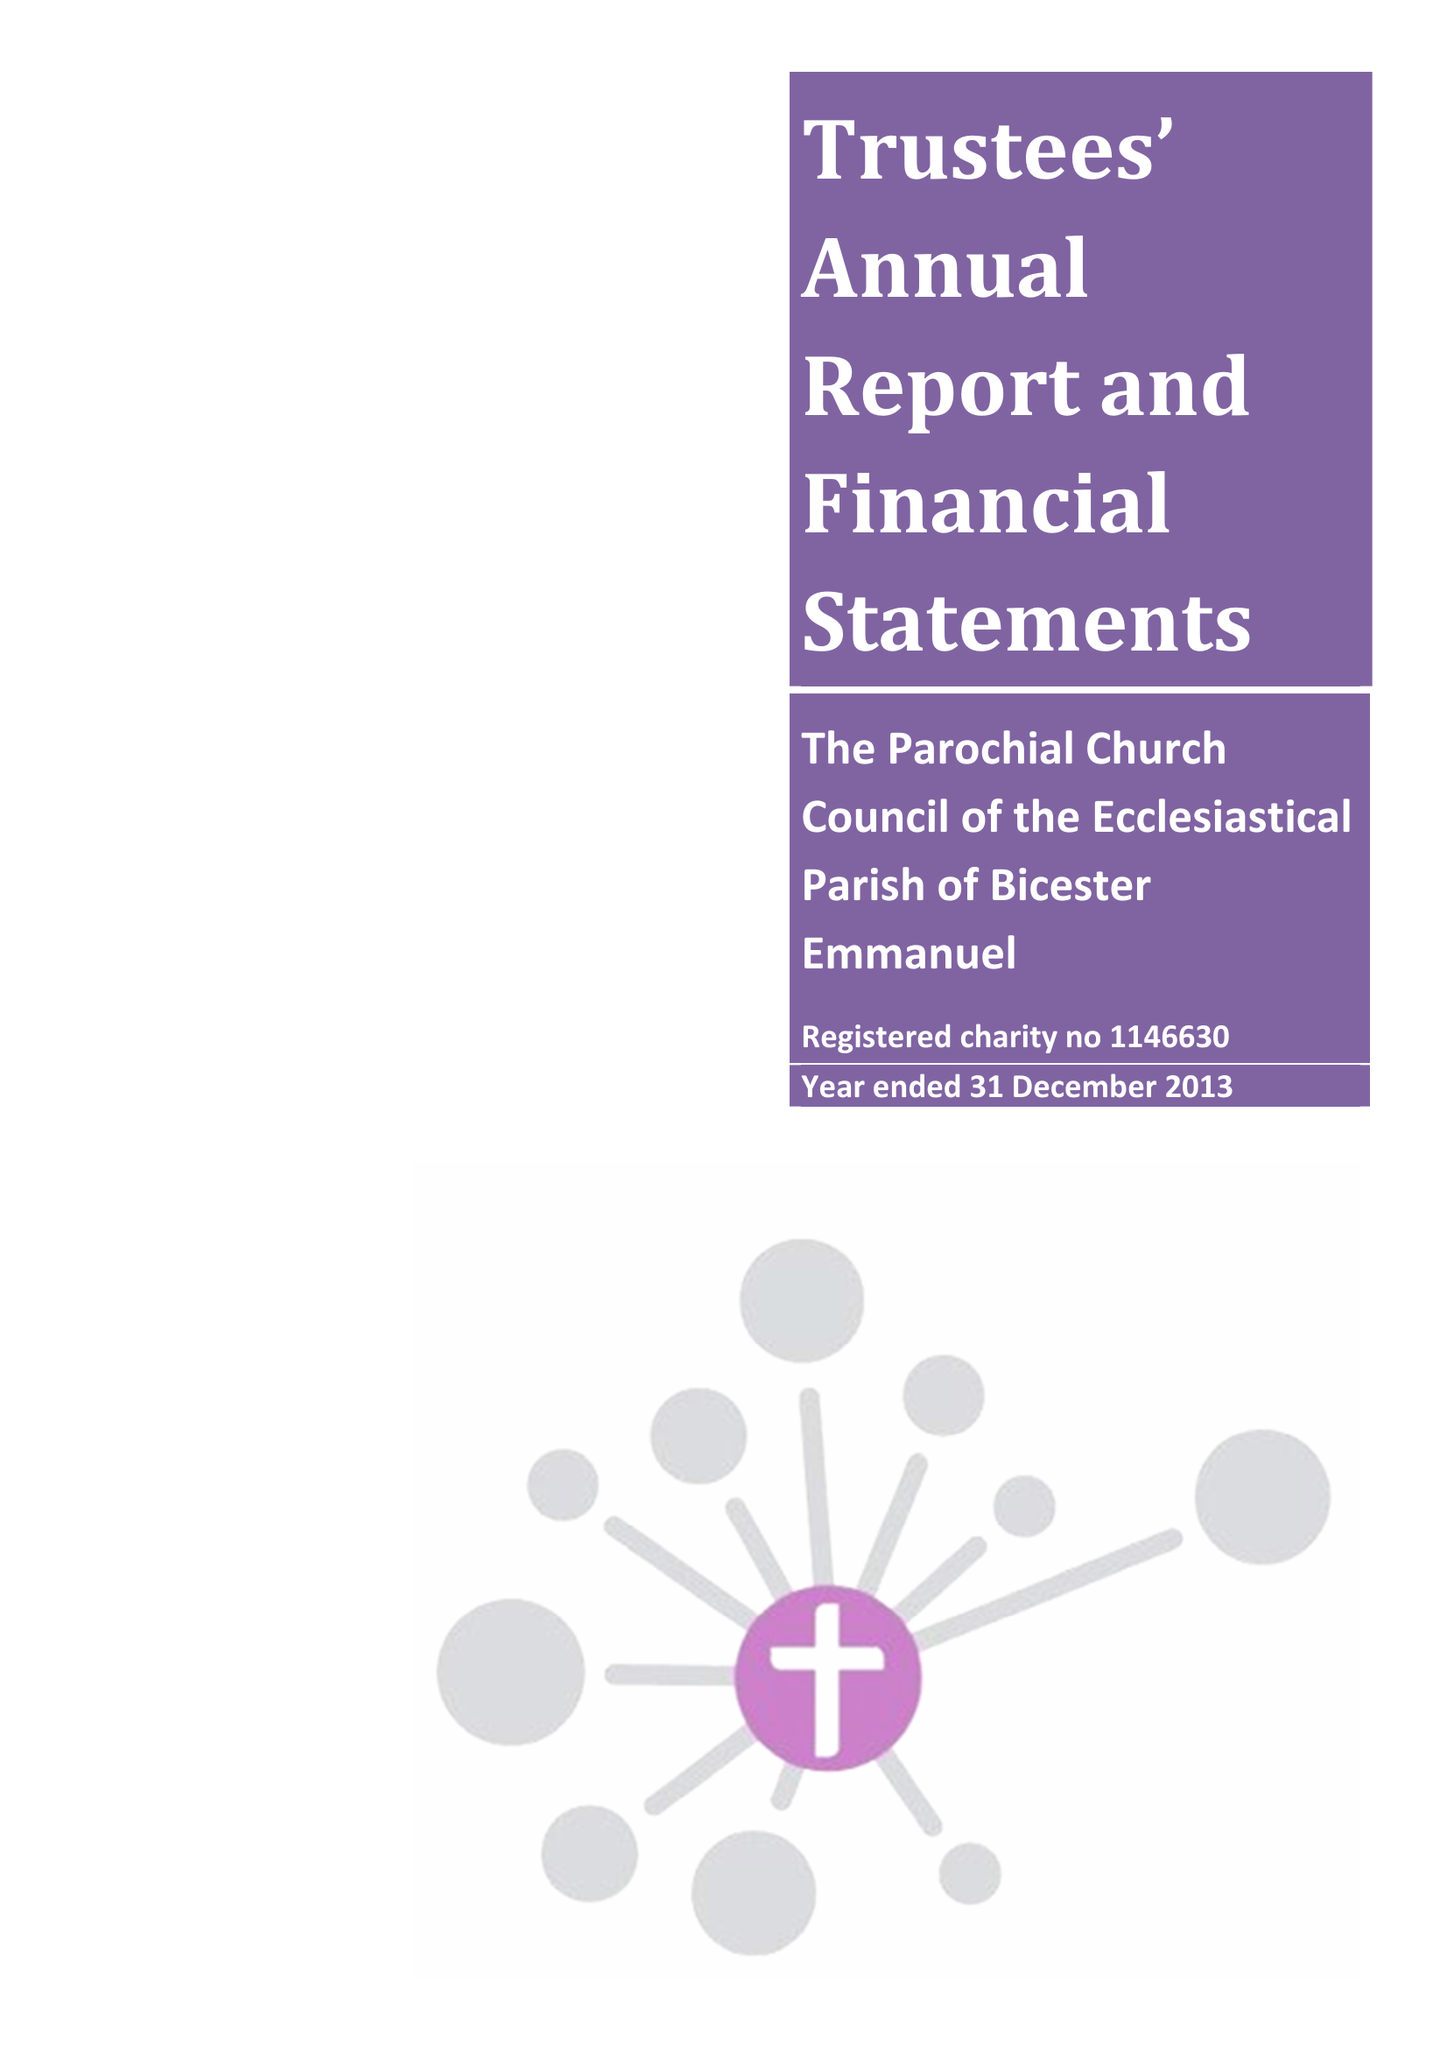What is the value for the address__post_town?
Answer the question using a single word or phrase. BICESTER 